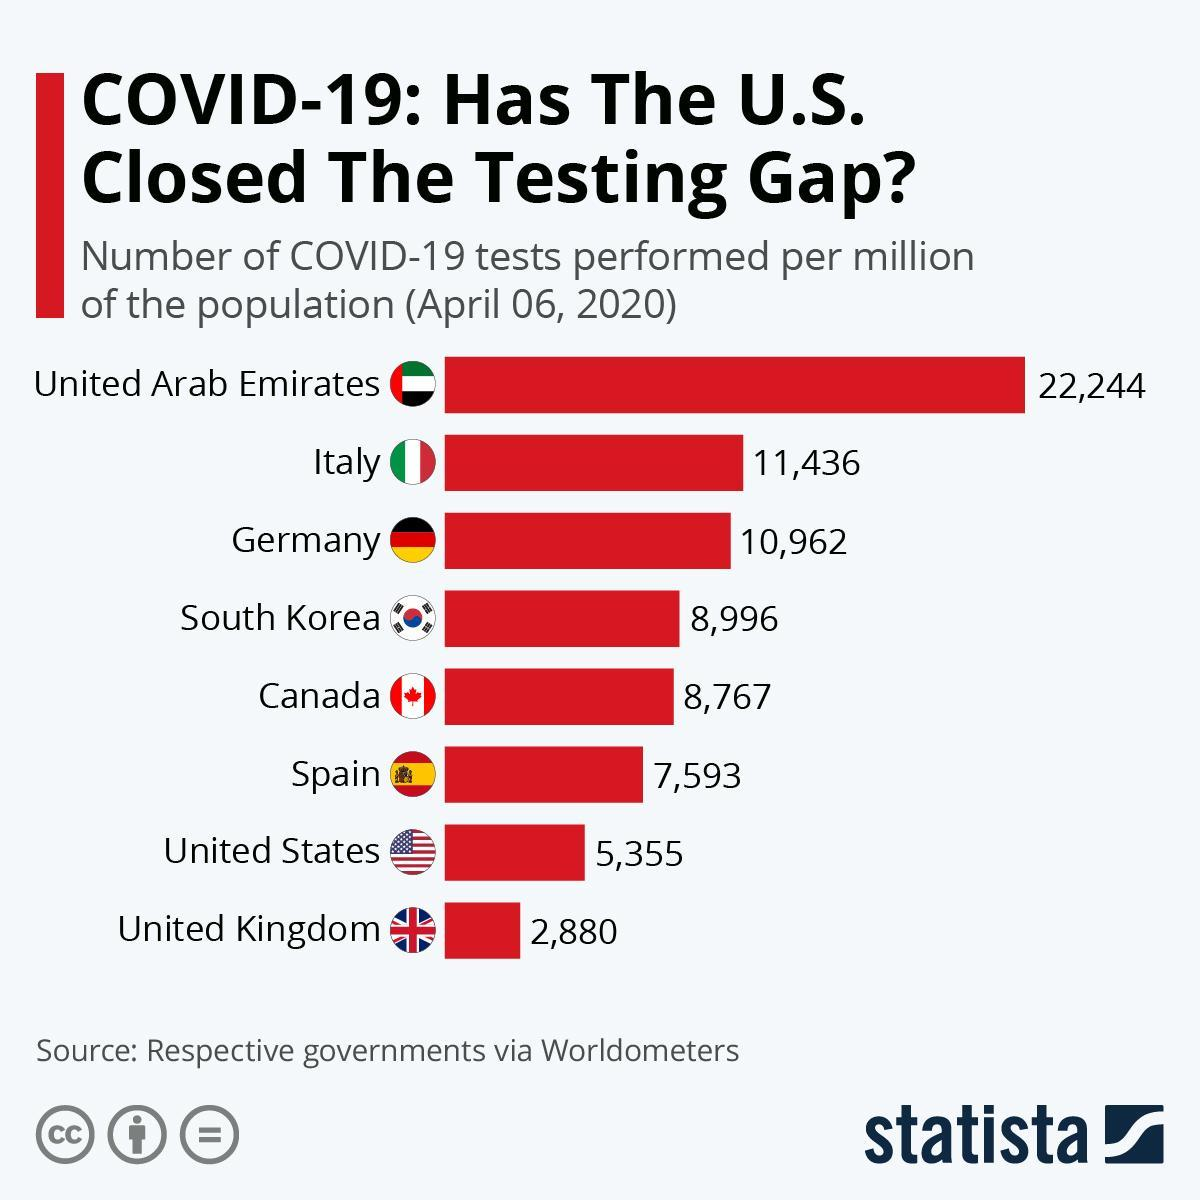What is the number of COVID-19 tests performed per million of the population in Germany as of April 06, 2020?
Answer the question with a short phrase. 10,962 Which country has performed the second-highest number of COVID-19 tests per million population among the selected countries as of April 06, 2020? Italy Which country has performed the least number of COVID-19 tests per million population among the selected countries as of April 06, 2020? United Kingdom What is the number of COVID-19 tests performed per million of the population in Canada as of April 06, 2020? 8,767 Which country has performed the highest number of COVID-19 tests per million population among the selected countries as of April 06, 2020? United Arab Emirates Which country has performed the second-least number of COVID-19 tests per million population among the selected countries as of April 06, 2020? United States What is the number of COVID-19 tests performed per million of the population in Spain as of April 06, 2020? 7,593 